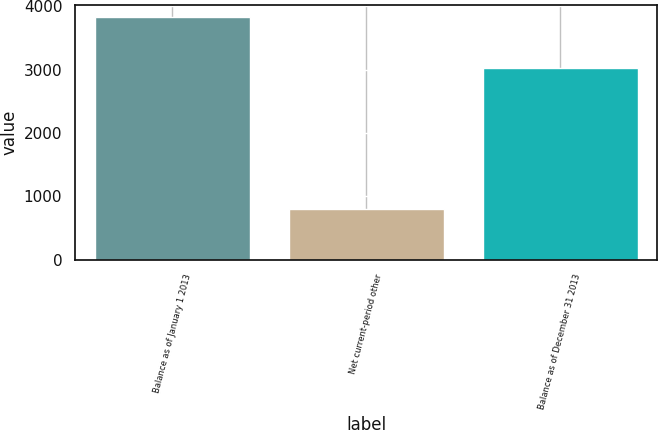Convert chart to OTSL. <chart><loc_0><loc_0><loc_500><loc_500><bar_chart><fcel>Balance as of January 1 2013<fcel>Net current-period other<fcel>Balance as of December 31 2013<nl><fcel>3827<fcel>798<fcel>3029<nl></chart> 